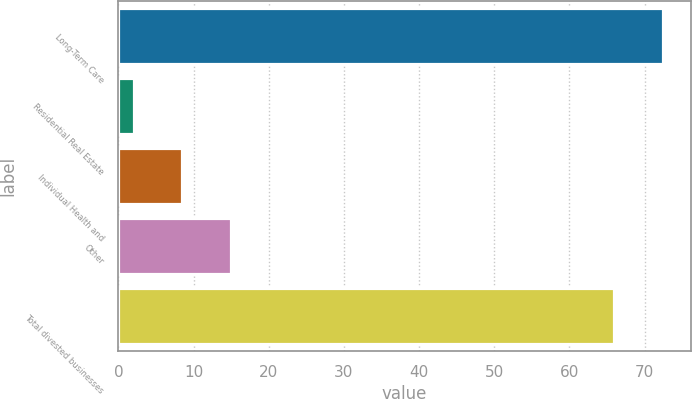Convert chart. <chart><loc_0><loc_0><loc_500><loc_500><bar_chart><fcel>Long-Term Care<fcel>Residential Real Estate<fcel>Individual Health and<fcel>Other<fcel>Total divested businesses<nl><fcel>72.5<fcel>2<fcel>8.5<fcel>15<fcel>66<nl></chart> 